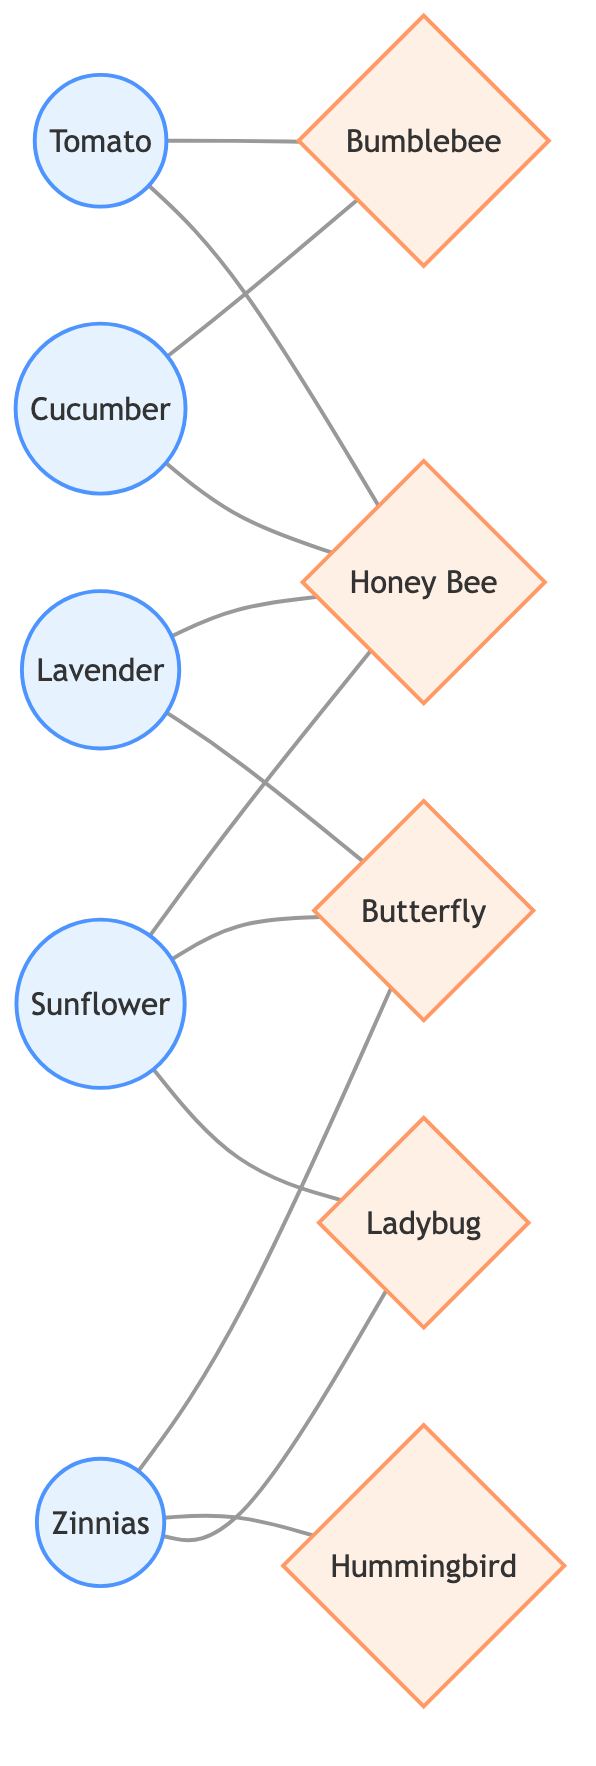What plants are connected to Bumblebee? To find the plants connected to Bumblebee, I check the edges that have Bumblebee as the target node. The sources for these edges are Tomato and Cucumber, which means both plants are connected to Bumblebee.
Answer: Tomato, Cucumber How many pollinators are connected to Sunflower? I look for edges where Sunflower is the source. The connected pollinators are Honey Bee, Butterfly, and Ladybug. This gives a total count of three connected pollinators.
Answer: 3 Which plants attract Butterfly? I need to check the edges originating from different plants that lead to Butterfly. The plants that connect to Butterfly are Sunflower, Lavender, and Zinnias.
Answer: Sunflower, Lavender, Zinnias What is the total number of plants in the diagram? I count all the unique nodes classified as plants in the diagram. The nodes are Tomato, Sunflower, Lavender, Cucumber, and Zinnias, which totals to five plants.
Answer: 5 Is Honey Bee connected to Zinnias? I check if there is an edge connecting Honey Bee and Zinnias. By examining the edges, I can see no direct connection from Zinnias to Honey Bee, so the answer is no.
Answer: No How many unique edges are in the graph overall? I count all the unique edges present in the diagram. The edges listed in the data show a total of twelve connections between plants and pollinators.
Answer: 12 Which pollinators are connected to Zinnias? I look for the edges where Zinnias is the source node. The connected pollinators are Butterfly, Hummingbird, and Ladybug.
Answer: Butterfly, Hummingbird, Ladybug Which pollinator is connected to the most number of plants? I analyze the edges to see how many sources connect to each pollinator. Bumblebee connects to two plants (Tomato, Cucumber), Honey Bee to three (Tomato, Sunflower, Cucumber), Butterfly to three (Sunflower, Lavender, Zinnias), Hummingbird to one (Zinnias), and Ladybug to two (Sunflower, Zinnias). The pollinators Honey Bee and Butterfly are tied for the highest count.
Answer: Honey Bee, Butterfly Which two plants share the same pollinator? I review connections to identify shared pollinators. Both Tomato and Cucumber share Honey Bee, while Sunflower and Zinnias share Ladybug. These pairs demonstrate mutual connections through the same pollinator.
Answer: Tomato, Cucumber; Sunflower, Zinnias 